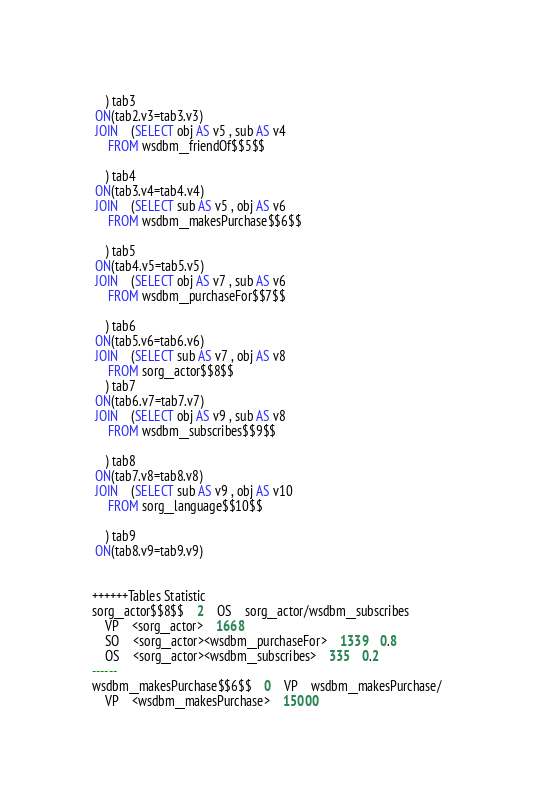<code> <loc_0><loc_0><loc_500><loc_500><_SQL_>	) tab3
 ON(tab2.v3=tab3.v3)
 JOIN    (SELECT obj AS v5 , sub AS v4 
	 FROM wsdbm__friendOf$$5$$
	
	) tab4
 ON(tab3.v4=tab4.v4)
 JOIN    (SELECT sub AS v5 , obj AS v6 
	 FROM wsdbm__makesPurchase$$6$$
	
	) tab5
 ON(tab4.v5=tab5.v5)
 JOIN    (SELECT obj AS v7 , sub AS v6 
	 FROM wsdbm__purchaseFor$$7$$
	
	) tab6
 ON(tab5.v6=tab6.v6)
 JOIN    (SELECT sub AS v7 , obj AS v8 
	 FROM sorg__actor$$8$$
	) tab7
 ON(tab6.v7=tab7.v7)
 JOIN    (SELECT obj AS v9 , sub AS v8 
	 FROM wsdbm__subscribes$$9$$
	
	) tab8
 ON(tab7.v8=tab8.v8)
 JOIN    (SELECT sub AS v9 , obj AS v10 
	 FROM sorg__language$$10$$
	
	) tab9
 ON(tab8.v9=tab9.v9)


++++++Tables Statistic
sorg__actor$$8$$	2	OS	sorg__actor/wsdbm__subscribes
	VP	<sorg__actor>	1668
	SO	<sorg__actor><wsdbm__purchaseFor>	1339	0.8
	OS	<sorg__actor><wsdbm__subscribes>	335	0.2
------
wsdbm__makesPurchase$$6$$	0	VP	wsdbm__makesPurchase/
	VP	<wsdbm__makesPurchase>	15000</code> 